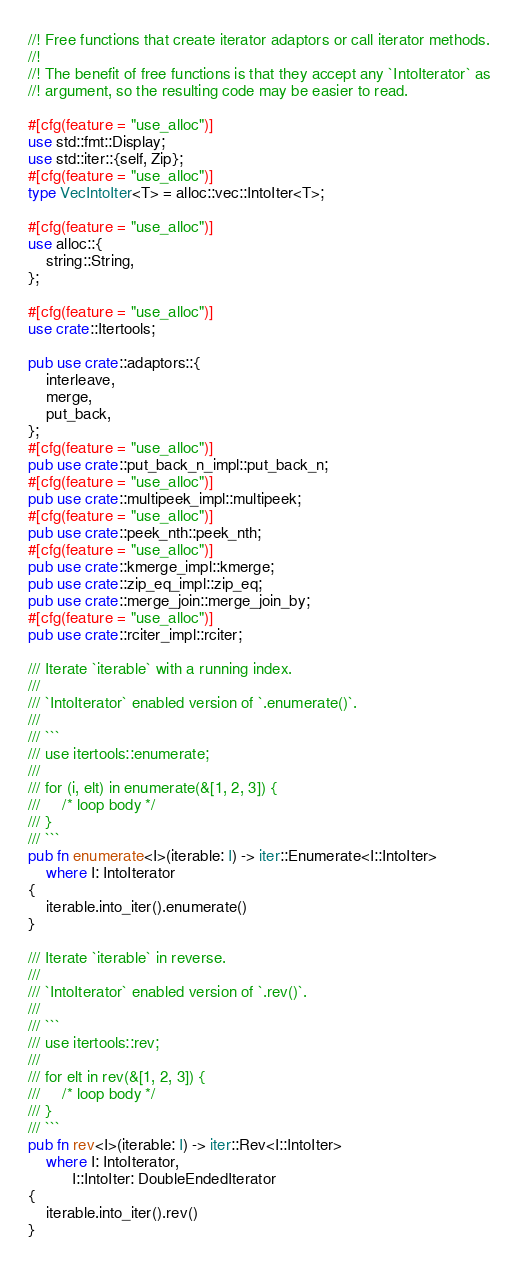<code> <loc_0><loc_0><loc_500><loc_500><_Rust_>//! Free functions that create iterator adaptors or call iterator methods.
//!
//! The benefit of free functions is that they accept any `IntoIterator` as
//! argument, so the resulting code may be easier to read.

#[cfg(feature = "use_alloc")]
use std::fmt::Display;
use std::iter::{self, Zip};
#[cfg(feature = "use_alloc")]
type VecIntoIter<T> = alloc::vec::IntoIter<T>;

#[cfg(feature = "use_alloc")]
use alloc::{
    string::String,
};

#[cfg(feature = "use_alloc")]
use crate::Itertools;

pub use crate::adaptors::{
    interleave,
    merge,
    put_back,
};
#[cfg(feature = "use_alloc")]
pub use crate::put_back_n_impl::put_back_n;
#[cfg(feature = "use_alloc")]
pub use crate::multipeek_impl::multipeek;
#[cfg(feature = "use_alloc")]
pub use crate::peek_nth::peek_nth;
#[cfg(feature = "use_alloc")]
pub use crate::kmerge_impl::kmerge;
pub use crate::zip_eq_impl::zip_eq;
pub use crate::merge_join::merge_join_by;
#[cfg(feature = "use_alloc")]
pub use crate::rciter_impl::rciter;

/// Iterate `iterable` with a running index.
///
/// `IntoIterator` enabled version of `.enumerate()`.
///
/// ```
/// use itertools::enumerate;
///
/// for (i, elt) in enumerate(&[1, 2, 3]) {
///     /* loop body */
/// }
/// ```
pub fn enumerate<I>(iterable: I) -> iter::Enumerate<I::IntoIter>
    where I: IntoIterator
{
    iterable.into_iter().enumerate()
}

/// Iterate `iterable` in reverse.
///
/// `IntoIterator` enabled version of `.rev()`.
///
/// ```
/// use itertools::rev;
///
/// for elt in rev(&[1, 2, 3]) {
///     /* loop body */
/// }
/// ```
pub fn rev<I>(iterable: I) -> iter::Rev<I::IntoIter>
    where I: IntoIterator,
          I::IntoIter: DoubleEndedIterator
{
    iterable.into_iter().rev()
}
</code> 